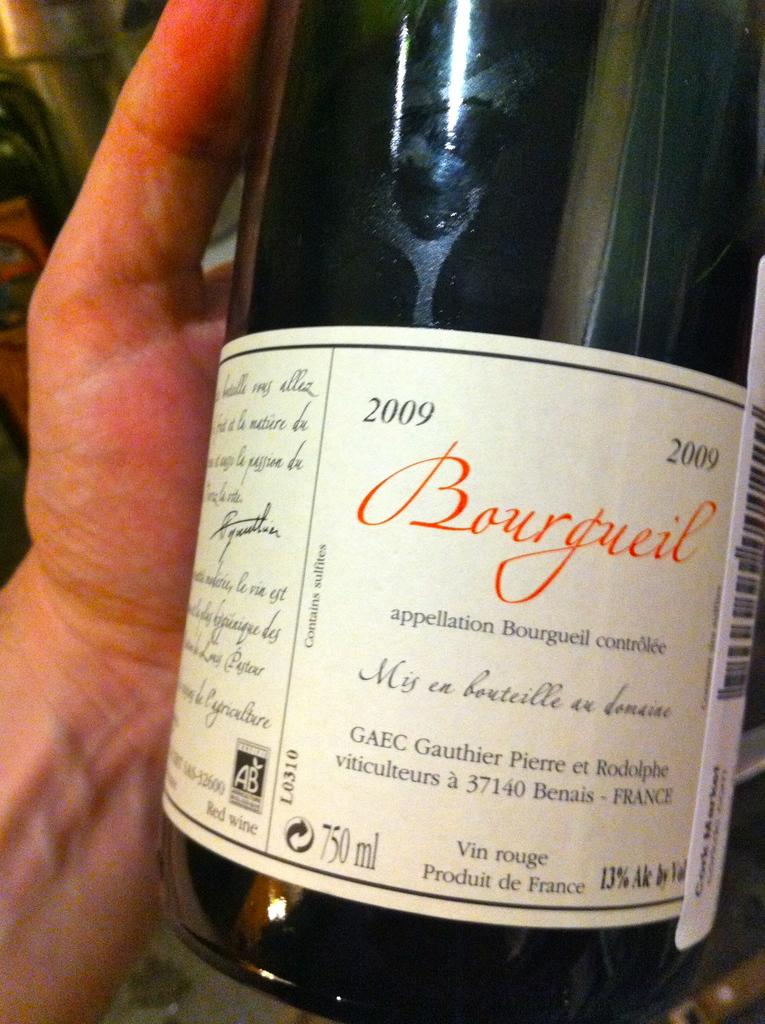<image>
Present a compact description of the photo's key features. A 2009 bottle of Bourgueil with 13% Alcohol by Volume 